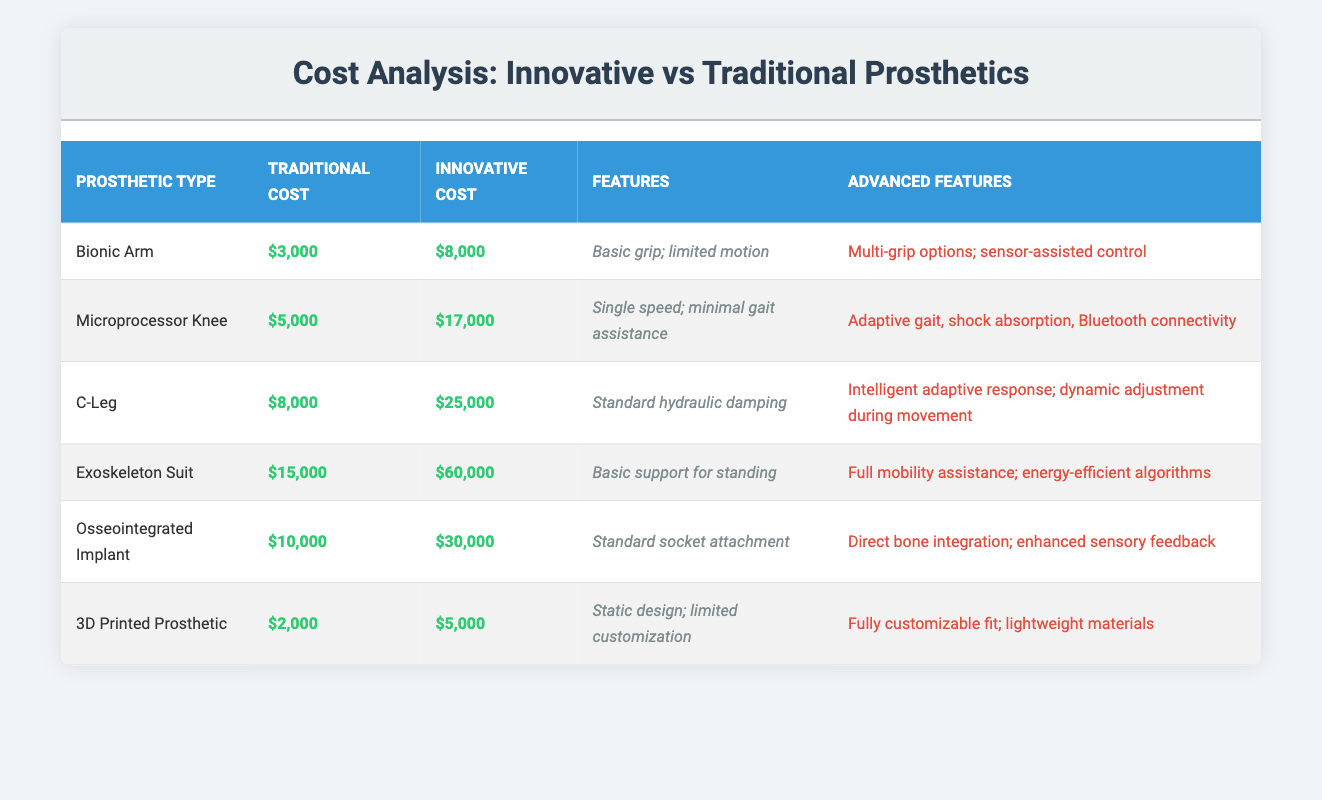What is the cost of the Bionic Arm? The cost of the Bionic Arm is listed in the "Traditional Cost" column as $3,000 and in the "Innovative Cost" column as $8,000.
Answer: $3,000 (Traditional), $8,000 (Innovative) Which prosthetic type has the highest innovative cost? By examining the "Innovative Cost" column, the Exoskeleton Suit has the highest cost at $60,000 when compared to all other types.
Answer: Exoskeleton Suit What is the difference in cost between the Traditional and Innovative models for the C-Leg? The Traditional Cost of the C-Leg is $8,000, and the Innovative Cost is $25,000. Subtracting the Traditional from the Innovative gives: $25,000 - $8,000 = $17,000.
Answer: $17,000 Is the Innovative Cost of the Microprocessor Knee higher than the Traditional Cost of the Exoskeleton Suit? The Innovative Cost of the Microprocessor Knee is $17,000, while the Traditional Cost of the Exoskeleton Suit is $15,000. Since $17,000 is greater than $15,000, the statement is true.
Answer: Yes What is the average Traditional Cost of the prosthetics listed? To find the average, sum the Traditional Costs: $3,000 + $5,000 + $8,000 + $15,000 + $10,000 + $2,000 = $43,000. Divide by the number of prosthetics (6): $43,000 / 6 = $7,166.67.
Answer: $7,166.67 Which type of prosthetic has the most advanced features? The Exoskeleton Suit has the most advanced features, providing full mobility assistance and energy-efficient algorithms. It stands out compared to others with more basic features.
Answer: Exoskeleton Suit What percentage more does the Innovative version of the Osseointegrated Implant cost compared to its Traditional counterpart? The Traditional Cost is $10,000 and the Innovative Cost is $30,000. The increase is $30,000 - $10,000 = $20,000. The percentage increase is ($20,000 / $10,000) * 100 = 200%.
Answer: 200% How many prosthetic types have more than a $10,000 difference between Traditional and Innovative Costs? The prosthetics with more than a $10,000 difference are the Microprocessor Knee ($12,000), C-Leg ($17,000), Exoskeleton Suit ($45,000), and Osseointegrated Implant ($20,000). Thus, there are four types.
Answer: 4 